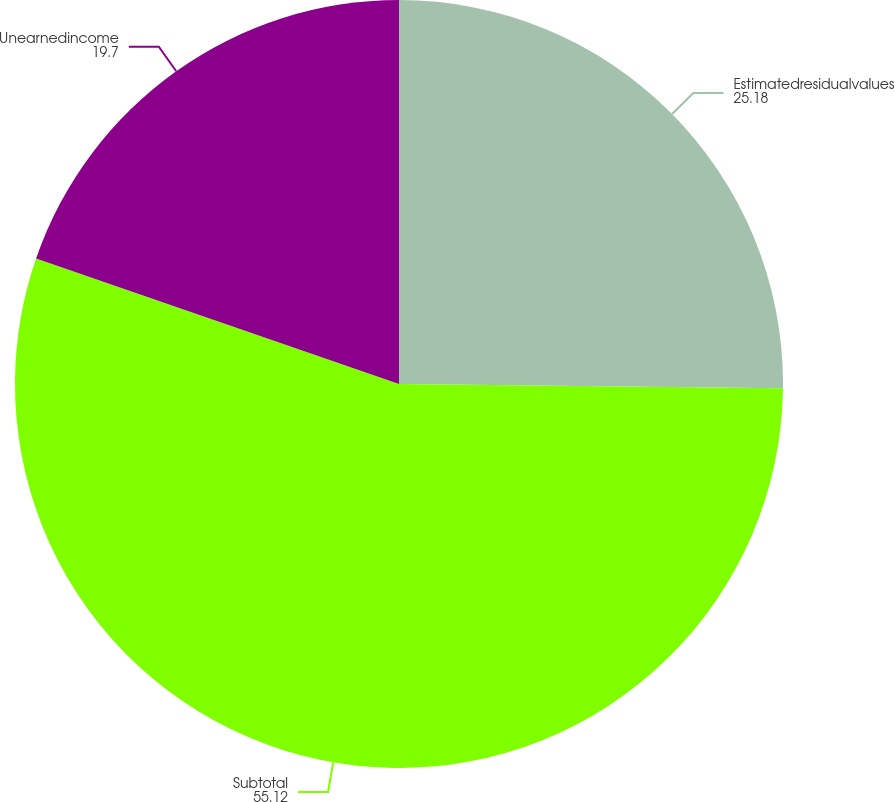Convert chart. <chart><loc_0><loc_0><loc_500><loc_500><pie_chart><fcel>Estimatedresidualvalues<fcel>Subtotal<fcel>Unearnedincome<nl><fcel>25.18%<fcel>55.12%<fcel>19.7%<nl></chart> 